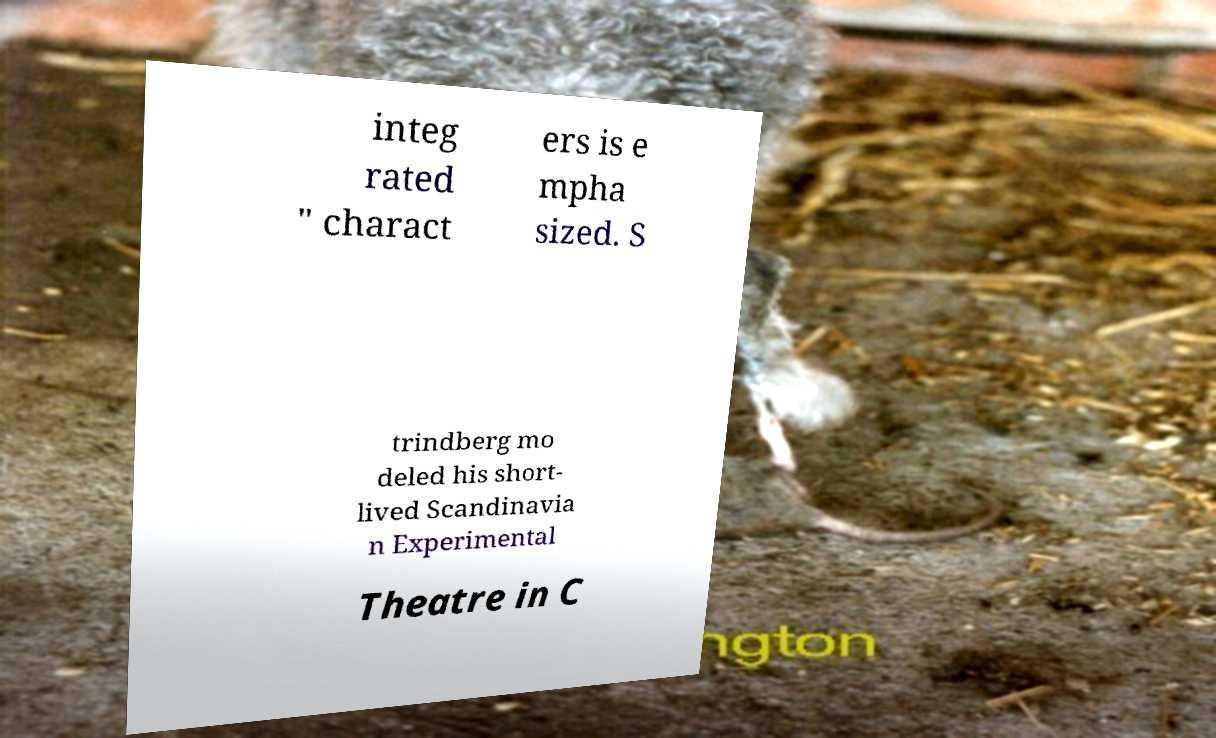Can you read and provide the text displayed in the image?This photo seems to have some interesting text. Can you extract and type it out for me? integ rated " charact ers is e mpha sized. S trindberg mo deled his short- lived Scandinavia n Experimental Theatre in C 